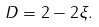Convert formula to latex. <formula><loc_0><loc_0><loc_500><loc_500>D = 2 - 2 \xi .</formula> 